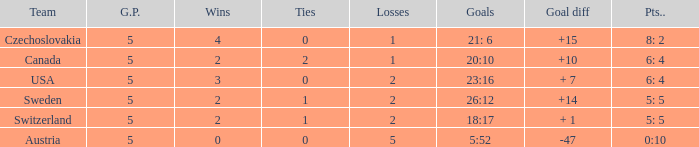When the g.p was above 5, what was the largest tie? None. 